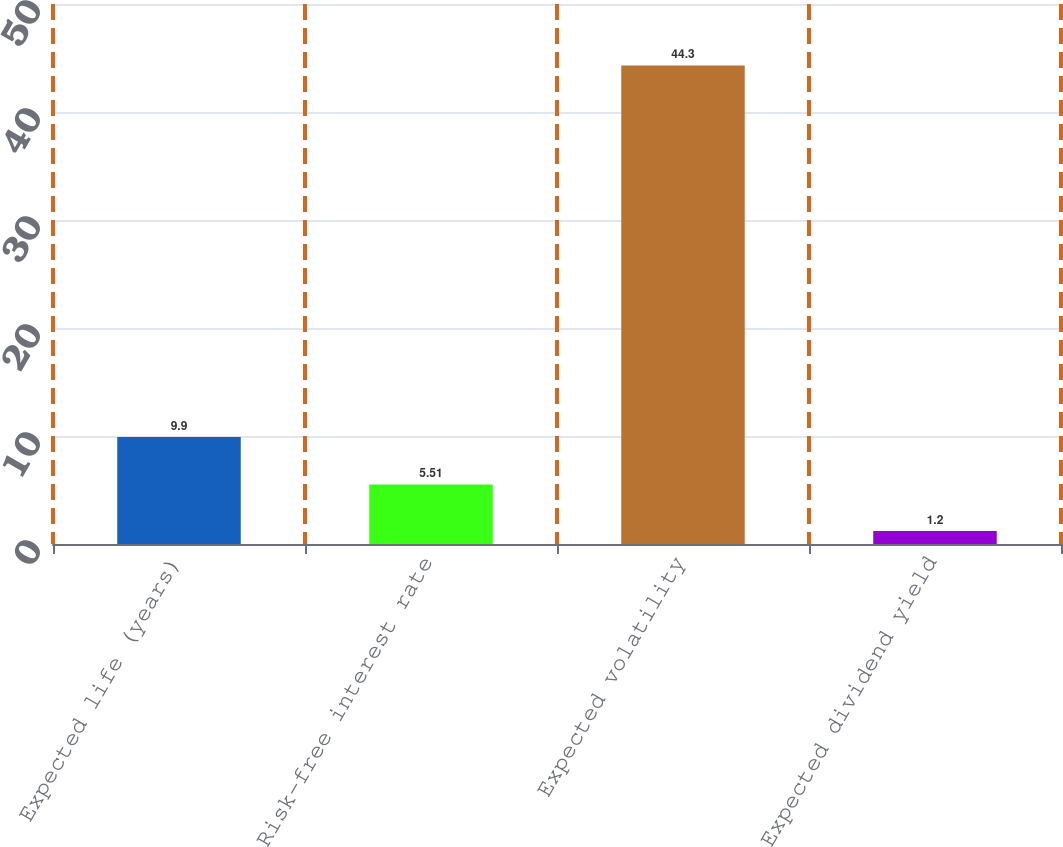Convert chart. <chart><loc_0><loc_0><loc_500><loc_500><bar_chart><fcel>Expected life (years)<fcel>Risk-free interest rate<fcel>Expected volatility<fcel>Expected dividend yield<nl><fcel>9.9<fcel>5.51<fcel>44.3<fcel>1.2<nl></chart> 